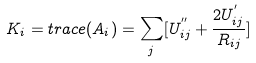Convert formula to latex. <formula><loc_0><loc_0><loc_500><loc_500>K _ { i } = t r a c e ( A _ { i } ) = \sum _ { j } [ U ^ { ^ { \prime \prime } } _ { i j } + \frac { 2 U ^ { ^ { \prime } } _ { i j } } { R _ { i j } } ]</formula> 